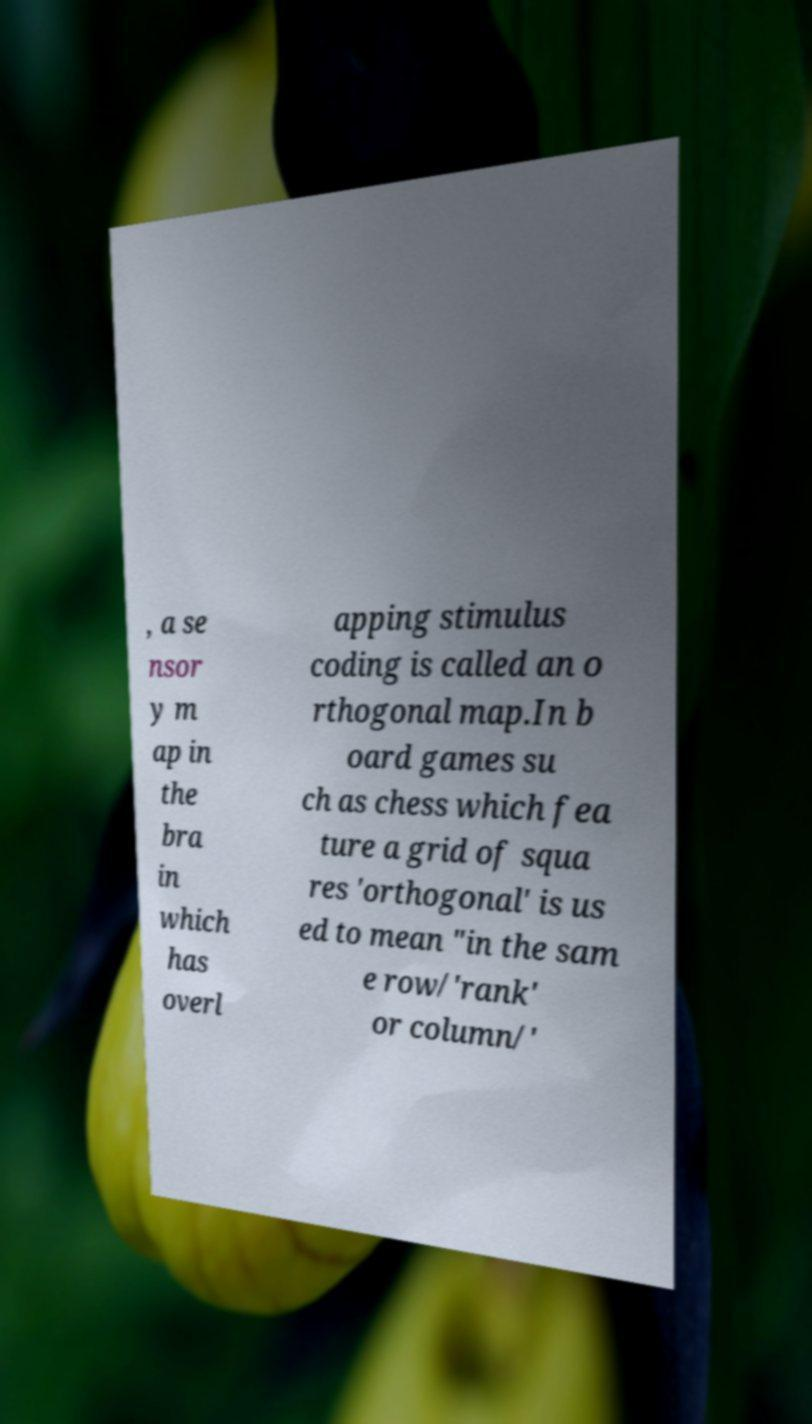What messages or text are displayed in this image? I need them in a readable, typed format. , a se nsor y m ap in the bra in which has overl apping stimulus coding is called an o rthogonal map.In b oard games su ch as chess which fea ture a grid of squa res 'orthogonal' is us ed to mean "in the sam e row/'rank' or column/' 